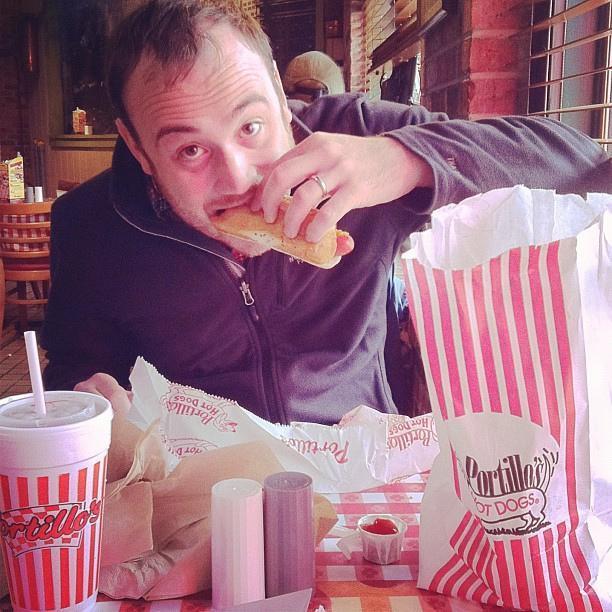How many people can be seen?
Give a very brief answer. 2. How many water ski board have yellow lights shedding on them?
Give a very brief answer. 0. 